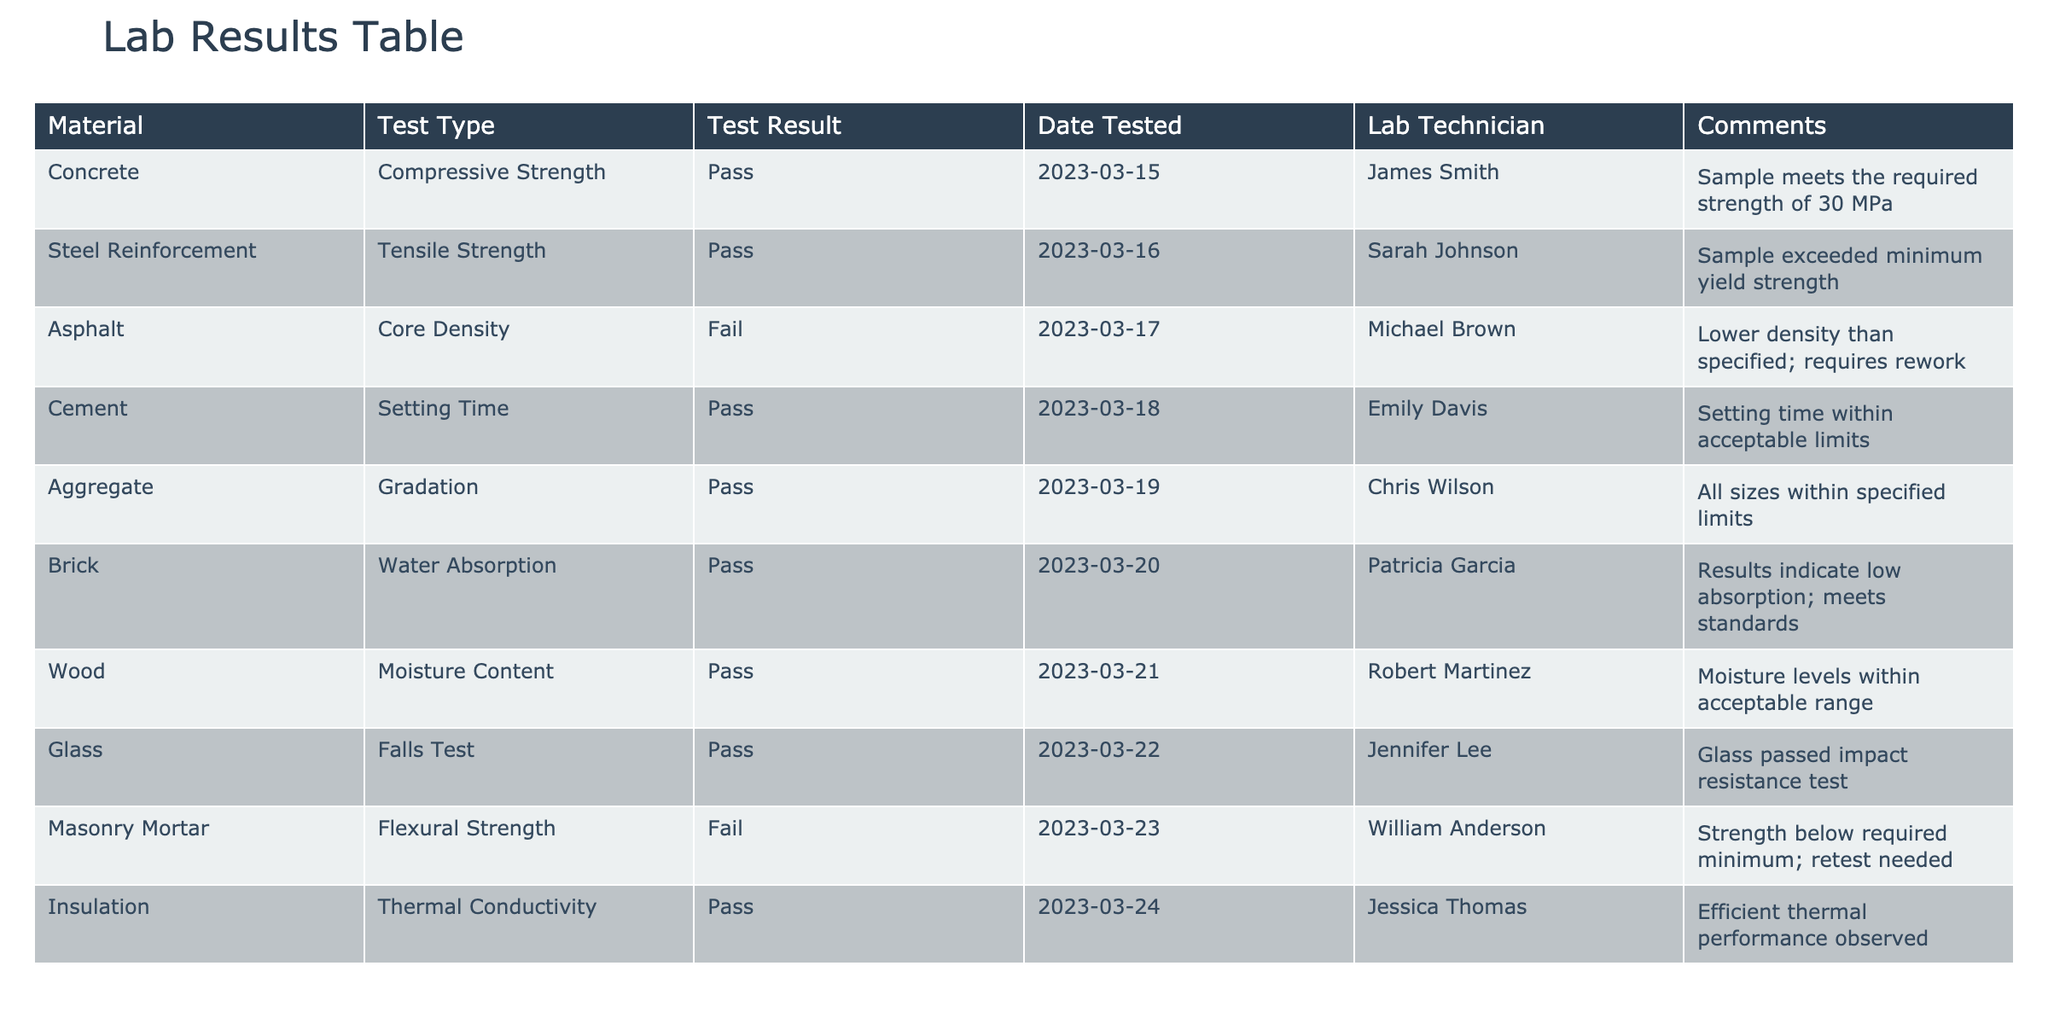What materials passed the tests? By reviewing the "Test Result" column, we can identify the materials that are marked as "Pass." These materials are Concrete, Steel Reinforcement, Cement, Aggregate, Brick, Wood, Glass, and Insulation.
Answer: Concrete, Steel Reinforcement, Cement, Aggregate, Brick, Wood, Glass, Insulation Which material failed the Core Density test? The table indicates the test results for Asphalt under the "Test Type" column, where the result in the "Test Result" column states "Fail". Thus, Asphalt is the material that did not meet the standards.
Answer: Asphalt What is the setting time result for Cement? The "Test Type" for Cement is "Setting Time," and the "Test Result" shows "Pass." Hence, the result is satisfactory according to the standards.
Answer: Pass How many materials passed the tests in total? To find the total number of materials that passed, we count the number of entries in the "Test Result" column that indicate "Pass." There are 8 such materials listed.
Answer: 8 What is the average number of days from test date to failure for the materials tested? We consider only the materials that failed, which are Asphalt (tested on 2023-03-17) and Masonry Mortar (tested on 2023-03-23). We calculate the number of days between the two test dates: Masonry Mortar - Asphalt = 6 days. We take the average for 2 materials: (6 / 2) = 3 days.
Answer: 3 days Did any material exceed the minimum yield strength? The Steel Reinforcement material passed the "Tensile Strength" test, indicating it exceeded the minimum yield strength. Checking this shows that a material indeed met and exceeded the required standard.
Answer: Yes Which test resulted in the lowest performance and what was the specific issue? The lowest performance is indicated by the "Masonry Mortar" failing the "Flexural Strength" test. The comments specify that the strength is below the required minimum and necessitates a retest.
Answer: Flexural Strength; strength below minimum What can be inferred about the moisture content in Wood based on the test result? The test result for Wood indicates "Pass" for "Moisture Content," and comments mention moisture levels within the acceptable range, signifying a satisfactory quality of material usage in construction.
Answer: Acceptable moisture levels 